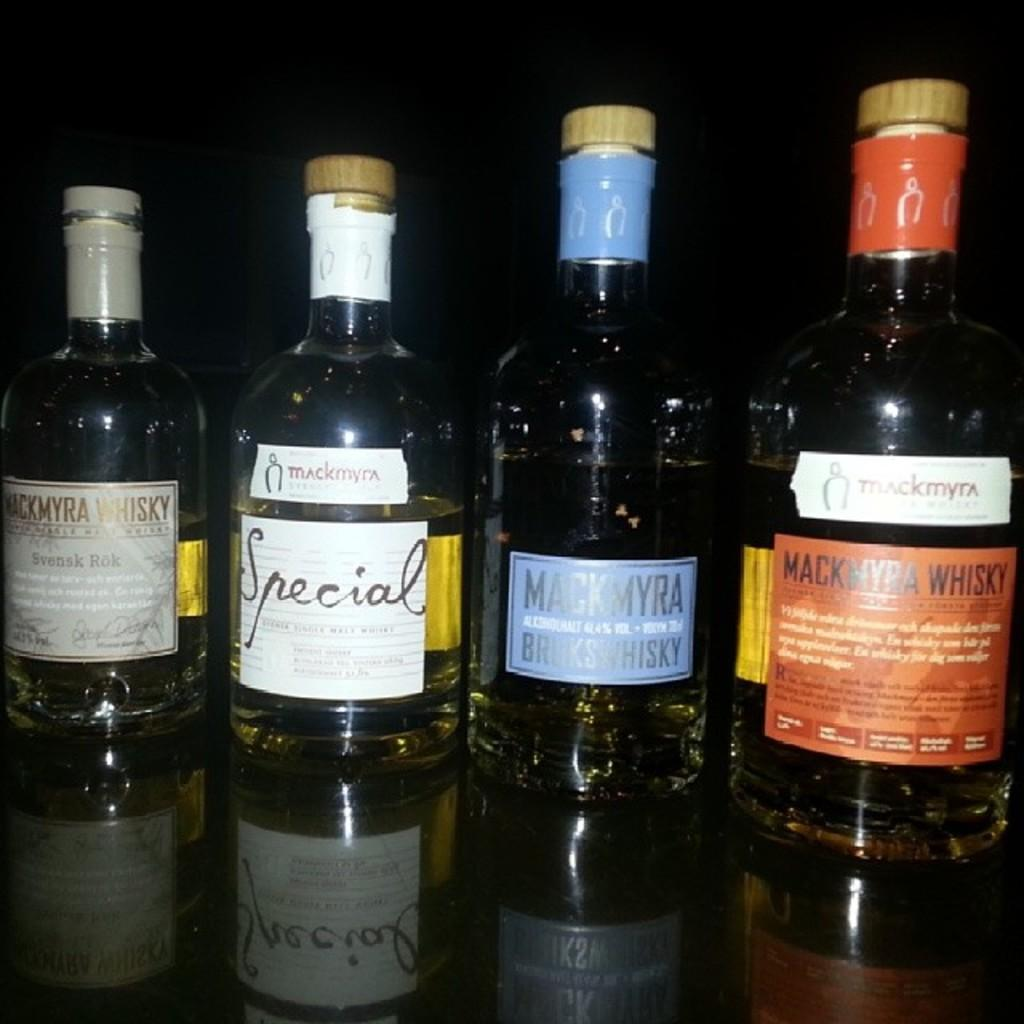<image>
Give a short and clear explanation of the subsequent image. Several bottles on a table, most of which contain Whisky. 